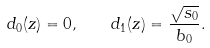<formula> <loc_0><loc_0><loc_500><loc_500>d _ { 0 } ( z ) = 0 , \quad d _ { 1 } ( z ) = \frac { \sqrt { s _ { 0 } } } { b _ { 0 } } .</formula> 